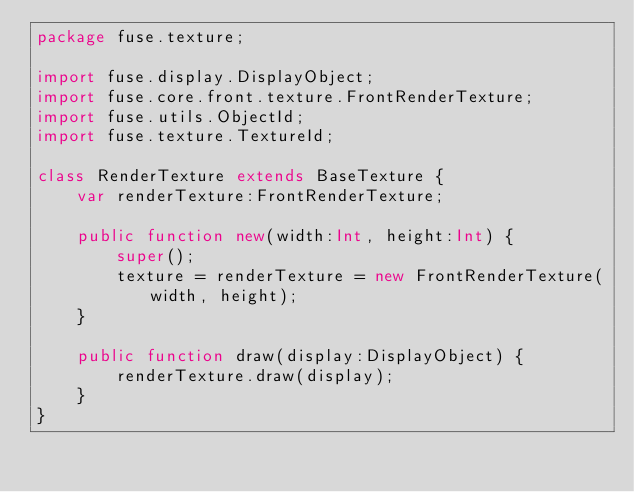<code> <loc_0><loc_0><loc_500><loc_500><_Haxe_>package fuse.texture;

import fuse.display.DisplayObject;
import fuse.core.front.texture.FrontRenderTexture;
import fuse.utils.ObjectId;
import fuse.texture.TextureId;

class RenderTexture extends BaseTexture {
	var renderTexture:FrontRenderTexture;

	public function new(width:Int, height:Int) {
		super();
		texture = renderTexture = new FrontRenderTexture(width, height);
	}

	public function draw(display:DisplayObject) {
		renderTexture.draw(display);
	}
}
</code> 